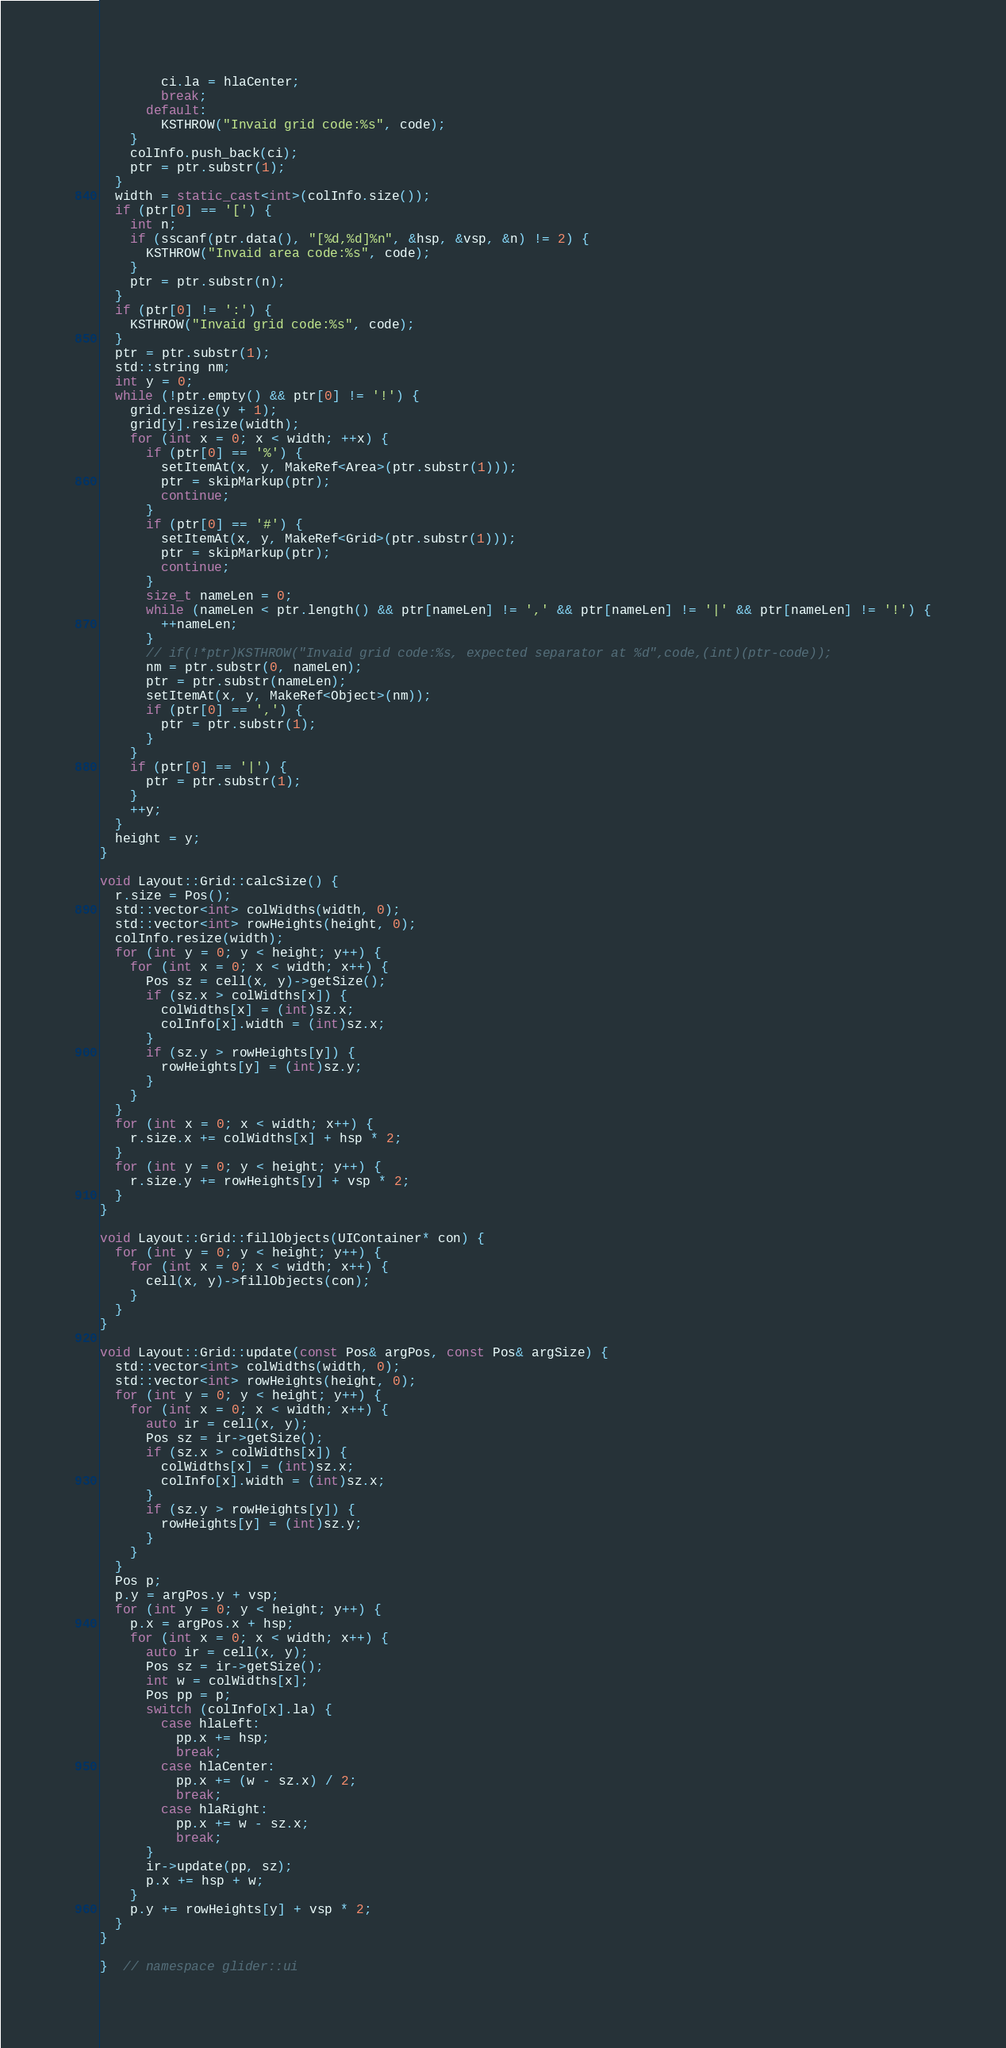<code> <loc_0><loc_0><loc_500><loc_500><_C++_>        ci.la = hlaCenter;
        break;
      default:
        KSTHROW("Invaid grid code:%s", code);
    }
    colInfo.push_back(ci);
    ptr = ptr.substr(1);
  }
  width = static_cast<int>(colInfo.size());
  if (ptr[0] == '[') {
    int n;
    if (sscanf(ptr.data(), "[%d,%d]%n", &hsp, &vsp, &n) != 2) {
      KSTHROW("Invaid area code:%s", code);
    }
    ptr = ptr.substr(n);
  }
  if (ptr[0] != ':') {
    KSTHROW("Invaid grid code:%s", code);
  }
  ptr = ptr.substr(1);
  std::string nm;
  int y = 0;
  while (!ptr.empty() && ptr[0] != '!') {
    grid.resize(y + 1);
    grid[y].resize(width);
    for (int x = 0; x < width; ++x) {
      if (ptr[0] == '%') {
        setItemAt(x, y, MakeRef<Area>(ptr.substr(1)));
        ptr = skipMarkup(ptr);
        continue;
      }
      if (ptr[0] == '#') {
        setItemAt(x, y, MakeRef<Grid>(ptr.substr(1)));
        ptr = skipMarkup(ptr);
        continue;
      }
      size_t nameLen = 0;
      while (nameLen < ptr.length() && ptr[nameLen] != ',' && ptr[nameLen] != '|' && ptr[nameLen] != '!') {
        ++nameLen;
      }
      // if(!*ptr)KSTHROW("Invaid grid code:%s, expected separator at %d",code,(int)(ptr-code));
      nm = ptr.substr(0, nameLen);
      ptr = ptr.substr(nameLen);
      setItemAt(x, y, MakeRef<Object>(nm));
      if (ptr[0] == ',') {
        ptr = ptr.substr(1);
      }
    }
    if (ptr[0] == '|') {
      ptr = ptr.substr(1);
    }
    ++y;
  }
  height = y;
}

void Layout::Grid::calcSize() {
  r.size = Pos();
  std::vector<int> colWidths(width, 0);
  std::vector<int> rowHeights(height, 0);
  colInfo.resize(width);
  for (int y = 0; y < height; y++) {
    for (int x = 0; x < width; x++) {
      Pos sz = cell(x, y)->getSize();
      if (sz.x > colWidths[x]) {
        colWidths[x] = (int)sz.x;
        colInfo[x].width = (int)sz.x;
      }
      if (sz.y > rowHeights[y]) {
        rowHeights[y] = (int)sz.y;
      }
    }
  }
  for (int x = 0; x < width; x++) {
    r.size.x += colWidths[x] + hsp * 2;
  }
  for (int y = 0; y < height; y++) {
    r.size.y += rowHeights[y] + vsp * 2;
  }
}

void Layout::Grid::fillObjects(UIContainer* con) {
  for (int y = 0; y < height; y++) {
    for (int x = 0; x < width; x++) {
      cell(x, y)->fillObjects(con);
    }
  }
}

void Layout::Grid::update(const Pos& argPos, const Pos& argSize) {
  std::vector<int> colWidths(width, 0);
  std::vector<int> rowHeights(height, 0);
  for (int y = 0; y < height; y++) {
    for (int x = 0; x < width; x++) {
      auto ir = cell(x, y);
      Pos sz = ir->getSize();
      if (sz.x > colWidths[x]) {
        colWidths[x] = (int)sz.x;
        colInfo[x].width = (int)sz.x;
      }
      if (sz.y > rowHeights[y]) {
        rowHeights[y] = (int)sz.y;
      }
    }
  }
  Pos p;
  p.y = argPos.y + vsp;
  for (int y = 0; y < height; y++) {
    p.x = argPos.x + hsp;
    for (int x = 0; x < width; x++) {
      auto ir = cell(x, y);
      Pos sz = ir->getSize();
      int w = colWidths[x];
      Pos pp = p;
      switch (colInfo[x].la) {
        case hlaLeft:
          pp.x += hsp;
          break;
        case hlaCenter:
          pp.x += (w - sz.x) / 2;
          break;
        case hlaRight:
          pp.x += w - sz.x;
          break;
      }
      ir->update(pp, sz);
      p.x += hsp + w;
    }
    p.y += rowHeights[y] + vsp * 2;
  }
}

}  // namespace glider::ui
</code> 